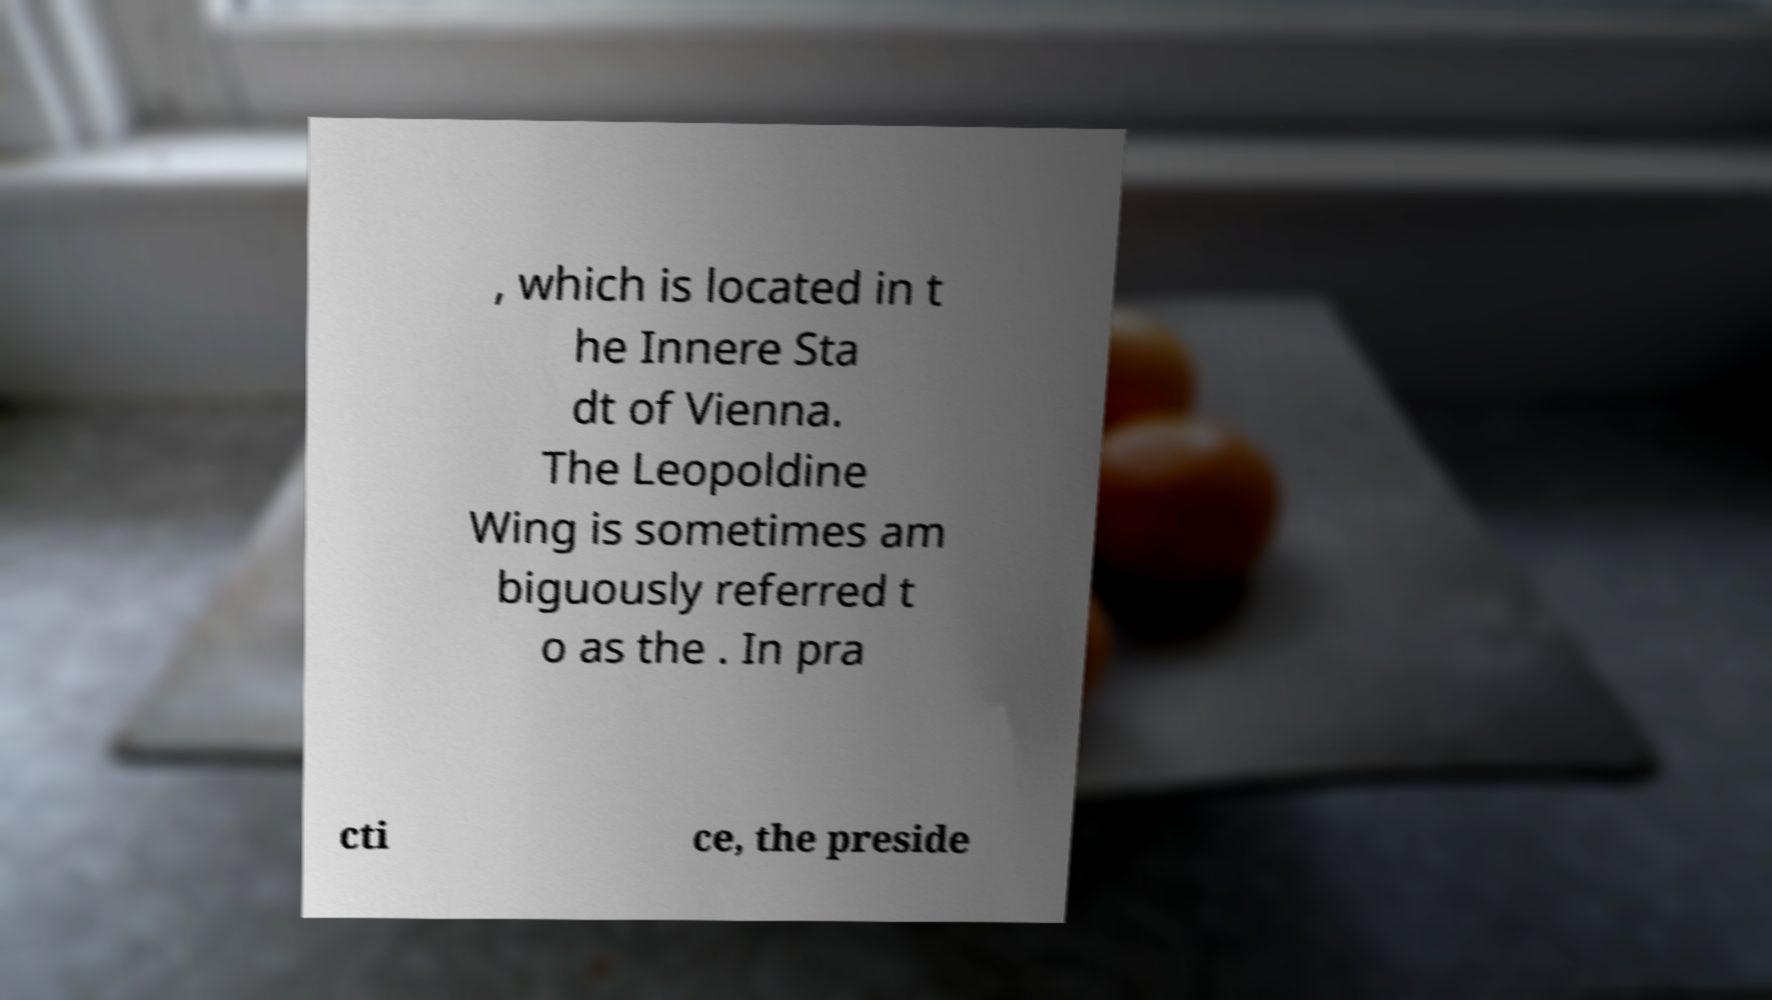What messages or text are displayed in this image? I need them in a readable, typed format. , which is located in t he Innere Sta dt of Vienna. The Leopoldine Wing is sometimes am biguously referred t o as the . In pra cti ce, the preside 